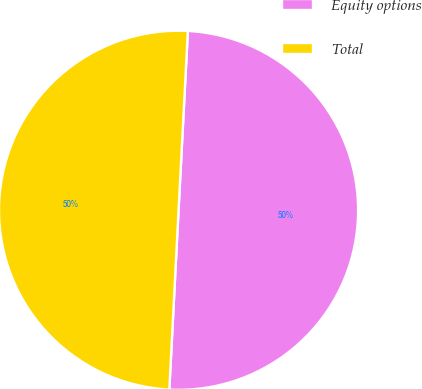<chart> <loc_0><loc_0><loc_500><loc_500><pie_chart><fcel>Equity options<fcel>Total<nl><fcel>49.99%<fcel>50.01%<nl></chart> 